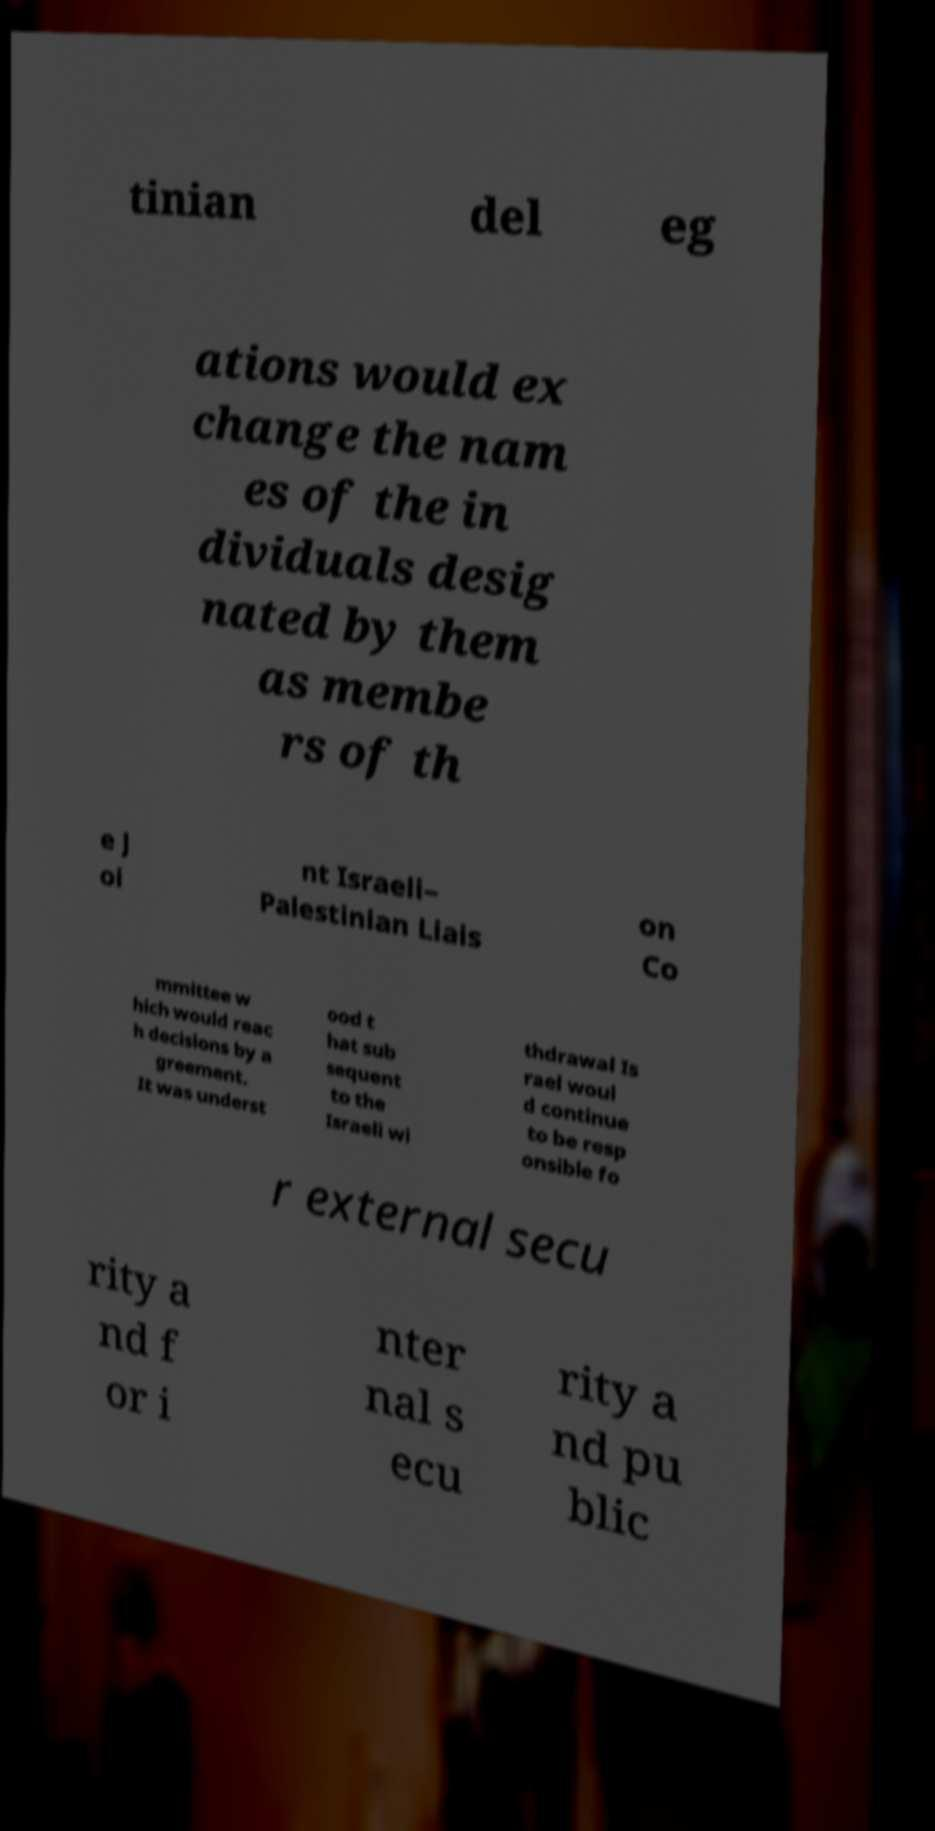Can you accurately transcribe the text from the provided image for me? tinian del eg ations would ex change the nam es of the in dividuals desig nated by them as membe rs of th e J oi nt Israeli– Palestinian Liais on Co mmittee w hich would reac h decisions by a greement. It was underst ood t hat sub sequent to the Israeli wi thdrawal Is rael woul d continue to be resp onsible fo r external secu rity a nd f or i nter nal s ecu rity a nd pu blic 